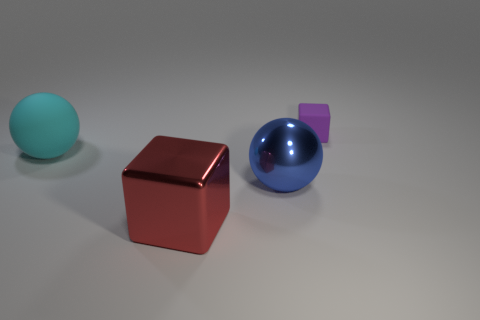Do the small purple thing and the large cyan object have the same shape? Although it may seem at first glance that their sizes are quite different, upon closer inspection, it is clear that both the small purple object and the large cyan object have spherical shapes. The illusion of a different shape possibly arises due to the difference in size and the angle from which we're viewing them. 